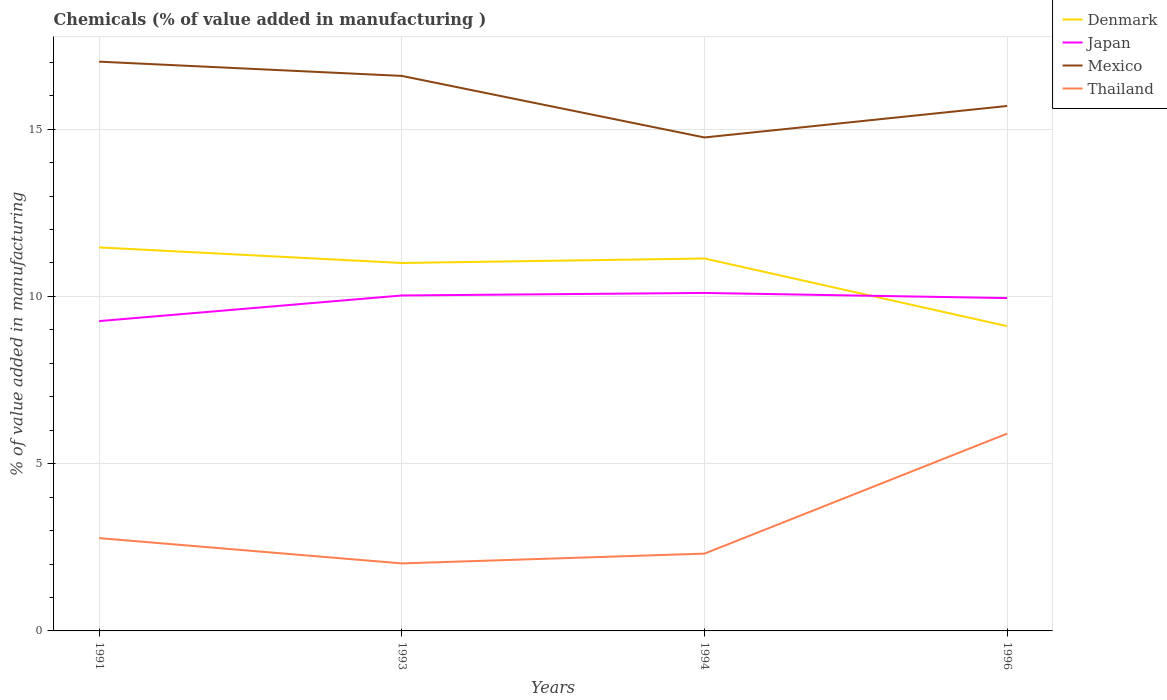How many different coloured lines are there?
Your response must be concise. 4. Does the line corresponding to Thailand intersect with the line corresponding to Japan?
Make the answer very short. No. Across all years, what is the maximum value added in manufacturing chemicals in Thailand?
Your answer should be compact. 2.02. What is the total value added in manufacturing chemicals in Japan in the graph?
Your answer should be compact. 0.15. What is the difference between the highest and the second highest value added in manufacturing chemicals in Mexico?
Ensure brevity in your answer.  2.27. How many years are there in the graph?
Provide a short and direct response. 4. Are the values on the major ticks of Y-axis written in scientific E-notation?
Offer a terse response. No. Does the graph contain any zero values?
Make the answer very short. No. Does the graph contain grids?
Your response must be concise. Yes. Where does the legend appear in the graph?
Provide a short and direct response. Top right. What is the title of the graph?
Offer a terse response. Chemicals (% of value added in manufacturing ). Does "Andorra" appear as one of the legend labels in the graph?
Offer a terse response. No. What is the label or title of the X-axis?
Offer a very short reply. Years. What is the label or title of the Y-axis?
Offer a very short reply. % of value added in manufacturing. What is the % of value added in manufacturing of Denmark in 1991?
Give a very brief answer. 11.47. What is the % of value added in manufacturing of Japan in 1991?
Your response must be concise. 9.26. What is the % of value added in manufacturing in Mexico in 1991?
Give a very brief answer. 17.02. What is the % of value added in manufacturing of Thailand in 1991?
Make the answer very short. 2.77. What is the % of value added in manufacturing in Denmark in 1993?
Offer a terse response. 11. What is the % of value added in manufacturing in Japan in 1993?
Give a very brief answer. 10.03. What is the % of value added in manufacturing of Mexico in 1993?
Provide a short and direct response. 16.59. What is the % of value added in manufacturing in Thailand in 1993?
Provide a succinct answer. 2.02. What is the % of value added in manufacturing of Denmark in 1994?
Make the answer very short. 11.13. What is the % of value added in manufacturing of Japan in 1994?
Provide a short and direct response. 10.1. What is the % of value added in manufacturing of Mexico in 1994?
Offer a very short reply. 14.75. What is the % of value added in manufacturing of Thailand in 1994?
Keep it short and to the point. 2.31. What is the % of value added in manufacturing of Denmark in 1996?
Your response must be concise. 9.11. What is the % of value added in manufacturing of Japan in 1996?
Your response must be concise. 9.95. What is the % of value added in manufacturing of Mexico in 1996?
Your answer should be very brief. 15.69. What is the % of value added in manufacturing of Thailand in 1996?
Offer a very short reply. 5.9. Across all years, what is the maximum % of value added in manufacturing in Denmark?
Provide a short and direct response. 11.47. Across all years, what is the maximum % of value added in manufacturing in Japan?
Provide a succinct answer. 10.1. Across all years, what is the maximum % of value added in manufacturing in Mexico?
Your response must be concise. 17.02. Across all years, what is the maximum % of value added in manufacturing in Thailand?
Provide a short and direct response. 5.9. Across all years, what is the minimum % of value added in manufacturing in Denmark?
Your response must be concise. 9.11. Across all years, what is the minimum % of value added in manufacturing in Japan?
Offer a very short reply. 9.26. Across all years, what is the minimum % of value added in manufacturing of Mexico?
Your answer should be very brief. 14.75. Across all years, what is the minimum % of value added in manufacturing in Thailand?
Provide a short and direct response. 2.02. What is the total % of value added in manufacturing of Denmark in the graph?
Keep it short and to the point. 42.71. What is the total % of value added in manufacturing of Japan in the graph?
Make the answer very short. 39.35. What is the total % of value added in manufacturing of Mexico in the graph?
Make the answer very short. 64.06. What is the total % of value added in manufacturing in Thailand in the graph?
Ensure brevity in your answer.  13. What is the difference between the % of value added in manufacturing of Denmark in 1991 and that in 1993?
Provide a succinct answer. 0.47. What is the difference between the % of value added in manufacturing of Japan in 1991 and that in 1993?
Provide a short and direct response. -0.77. What is the difference between the % of value added in manufacturing of Mexico in 1991 and that in 1993?
Make the answer very short. 0.43. What is the difference between the % of value added in manufacturing in Thailand in 1991 and that in 1993?
Ensure brevity in your answer.  0.76. What is the difference between the % of value added in manufacturing of Denmark in 1991 and that in 1994?
Offer a terse response. 0.33. What is the difference between the % of value added in manufacturing of Japan in 1991 and that in 1994?
Your response must be concise. -0.84. What is the difference between the % of value added in manufacturing in Mexico in 1991 and that in 1994?
Give a very brief answer. 2.27. What is the difference between the % of value added in manufacturing in Thailand in 1991 and that in 1994?
Provide a succinct answer. 0.46. What is the difference between the % of value added in manufacturing of Denmark in 1991 and that in 1996?
Offer a terse response. 2.35. What is the difference between the % of value added in manufacturing of Japan in 1991 and that in 1996?
Offer a terse response. -0.69. What is the difference between the % of value added in manufacturing in Mexico in 1991 and that in 1996?
Make the answer very short. 1.32. What is the difference between the % of value added in manufacturing in Thailand in 1991 and that in 1996?
Your answer should be compact. -3.12. What is the difference between the % of value added in manufacturing of Denmark in 1993 and that in 1994?
Your answer should be very brief. -0.13. What is the difference between the % of value added in manufacturing of Japan in 1993 and that in 1994?
Give a very brief answer. -0.08. What is the difference between the % of value added in manufacturing of Mexico in 1993 and that in 1994?
Your answer should be compact. 1.84. What is the difference between the % of value added in manufacturing in Thailand in 1993 and that in 1994?
Your answer should be compact. -0.29. What is the difference between the % of value added in manufacturing of Denmark in 1993 and that in 1996?
Provide a succinct answer. 1.89. What is the difference between the % of value added in manufacturing of Japan in 1993 and that in 1996?
Offer a very short reply. 0.08. What is the difference between the % of value added in manufacturing of Mexico in 1993 and that in 1996?
Offer a very short reply. 0.9. What is the difference between the % of value added in manufacturing of Thailand in 1993 and that in 1996?
Keep it short and to the point. -3.88. What is the difference between the % of value added in manufacturing in Denmark in 1994 and that in 1996?
Offer a terse response. 2.02. What is the difference between the % of value added in manufacturing of Japan in 1994 and that in 1996?
Ensure brevity in your answer.  0.15. What is the difference between the % of value added in manufacturing of Mexico in 1994 and that in 1996?
Offer a terse response. -0.94. What is the difference between the % of value added in manufacturing of Thailand in 1994 and that in 1996?
Your answer should be compact. -3.59. What is the difference between the % of value added in manufacturing in Denmark in 1991 and the % of value added in manufacturing in Japan in 1993?
Your response must be concise. 1.44. What is the difference between the % of value added in manufacturing of Denmark in 1991 and the % of value added in manufacturing of Mexico in 1993?
Offer a very short reply. -5.13. What is the difference between the % of value added in manufacturing in Denmark in 1991 and the % of value added in manufacturing in Thailand in 1993?
Offer a terse response. 9.45. What is the difference between the % of value added in manufacturing in Japan in 1991 and the % of value added in manufacturing in Mexico in 1993?
Provide a succinct answer. -7.33. What is the difference between the % of value added in manufacturing of Japan in 1991 and the % of value added in manufacturing of Thailand in 1993?
Your response must be concise. 7.24. What is the difference between the % of value added in manufacturing in Mexico in 1991 and the % of value added in manufacturing in Thailand in 1993?
Offer a very short reply. 15. What is the difference between the % of value added in manufacturing of Denmark in 1991 and the % of value added in manufacturing of Japan in 1994?
Give a very brief answer. 1.36. What is the difference between the % of value added in manufacturing of Denmark in 1991 and the % of value added in manufacturing of Mexico in 1994?
Give a very brief answer. -3.29. What is the difference between the % of value added in manufacturing in Denmark in 1991 and the % of value added in manufacturing in Thailand in 1994?
Offer a terse response. 9.15. What is the difference between the % of value added in manufacturing in Japan in 1991 and the % of value added in manufacturing in Mexico in 1994?
Your answer should be compact. -5.49. What is the difference between the % of value added in manufacturing in Japan in 1991 and the % of value added in manufacturing in Thailand in 1994?
Offer a very short reply. 6.95. What is the difference between the % of value added in manufacturing in Mexico in 1991 and the % of value added in manufacturing in Thailand in 1994?
Give a very brief answer. 14.71. What is the difference between the % of value added in manufacturing of Denmark in 1991 and the % of value added in manufacturing of Japan in 1996?
Your answer should be very brief. 1.52. What is the difference between the % of value added in manufacturing in Denmark in 1991 and the % of value added in manufacturing in Mexico in 1996?
Offer a terse response. -4.23. What is the difference between the % of value added in manufacturing in Denmark in 1991 and the % of value added in manufacturing in Thailand in 1996?
Offer a very short reply. 5.57. What is the difference between the % of value added in manufacturing in Japan in 1991 and the % of value added in manufacturing in Mexico in 1996?
Keep it short and to the point. -6.43. What is the difference between the % of value added in manufacturing in Japan in 1991 and the % of value added in manufacturing in Thailand in 1996?
Provide a short and direct response. 3.36. What is the difference between the % of value added in manufacturing in Mexico in 1991 and the % of value added in manufacturing in Thailand in 1996?
Your response must be concise. 11.12. What is the difference between the % of value added in manufacturing in Denmark in 1993 and the % of value added in manufacturing in Japan in 1994?
Offer a very short reply. 0.9. What is the difference between the % of value added in manufacturing of Denmark in 1993 and the % of value added in manufacturing of Mexico in 1994?
Offer a very short reply. -3.75. What is the difference between the % of value added in manufacturing of Denmark in 1993 and the % of value added in manufacturing of Thailand in 1994?
Ensure brevity in your answer.  8.69. What is the difference between the % of value added in manufacturing in Japan in 1993 and the % of value added in manufacturing in Mexico in 1994?
Offer a very short reply. -4.72. What is the difference between the % of value added in manufacturing in Japan in 1993 and the % of value added in manufacturing in Thailand in 1994?
Your answer should be very brief. 7.72. What is the difference between the % of value added in manufacturing in Mexico in 1993 and the % of value added in manufacturing in Thailand in 1994?
Provide a succinct answer. 14.28. What is the difference between the % of value added in manufacturing in Denmark in 1993 and the % of value added in manufacturing in Japan in 1996?
Offer a terse response. 1.05. What is the difference between the % of value added in manufacturing of Denmark in 1993 and the % of value added in manufacturing of Mexico in 1996?
Offer a terse response. -4.69. What is the difference between the % of value added in manufacturing in Denmark in 1993 and the % of value added in manufacturing in Thailand in 1996?
Keep it short and to the point. 5.1. What is the difference between the % of value added in manufacturing of Japan in 1993 and the % of value added in manufacturing of Mexico in 1996?
Provide a short and direct response. -5.67. What is the difference between the % of value added in manufacturing in Japan in 1993 and the % of value added in manufacturing in Thailand in 1996?
Keep it short and to the point. 4.13. What is the difference between the % of value added in manufacturing of Mexico in 1993 and the % of value added in manufacturing of Thailand in 1996?
Your answer should be compact. 10.69. What is the difference between the % of value added in manufacturing in Denmark in 1994 and the % of value added in manufacturing in Japan in 1996?
Your answer should be compact. 1.18. What is the difference between the % of value added in manufacturing of Denmark in 1994 and the % of value added in manufacturing of Mexico in 1996?
Provide a succinct answer. -4.56. What is the difference between the % of value added in manufacturing of Denmark in 1994 and the % of value added in manufacturing of Thailand in 1996?
Offer a terse response. 5.23. What is the difference between the % of value added in manufacturing of Japan in 1994 and the % of value added in manufacturing of Mexico in 1996?
Offer a terse response. -5.59. What is the difference between the % of value added in manufacturing of Japan in 1994 and the % of value added in manufacturing of Thailand in 1996?
Your response must be concise. 4.21. What is the difference between the % of value added in manufacturing of Mexico in 1994 and the % of value added in manufacturing of Thailand in 1996?
Your answer should be compact. 8.85. What is the average % of value added in manufacturing of Denmark per year?
Make the answer very short. 10.68. What is the average % of value added in manufacturing of Japan per year?
Make the answer very short. 9.84. What is the average % of value added in manufacturing in Mexico per year?
Your answer should be very brief. 16.01. What is the average % of value added in manufacturing of Thailand per year?
Provide a short and direct response. 3.25. In the year 1991, what is the difference between the % of value added in manufacturing of Denmark and % of value added in manufacturing of Japan?
Make the answer very short. 2.2. In the year 1991, what is the difference between the % of value added in manufacturing in Denmark and % of value added in manufacturing in Mexico?
Offer a very short reply. -5.55. In the year 1991, what is the difference between the % of value added in manufacturing of Denmark and % of value added in manufacturing of Thailand?
Your answer should be compact. 8.69. In the year 1991, what is the difference between the % of value added in manufacturing in Japan and % of value added in manufacturing in Mexico?
Provide a succinct answer. -7.76. In the year 1991, what is the difference between the % of value added in manufacturing of Japan and % of value added in manufacturing of Thailand?
Your response must be concise. 6.49. In the year 1991, what is the difference between the % of value added in manufacturing in Mexico and % of value added in manufacturing in Thailand?
Make the answer very short. 14.24. In the year 1993, what is the difference between the % of value added in manufacturing of Denmark and % of value added in manufacturing of Japan?
Give a very brief answer. 0.97. In the year 1993, what is the difference between the % of value added in manufacturing in Denmark and % of value added in manufacturing in Mexico?
Offer a terse response. -5.59. In the year 1993, what is the difference between the % of value added in manufacturing of Denmark and % of value added in manufacturing of Thailand?
Your response must be concise. 8.98. In the year 1993, what is the difference between the % of value added in manufacturing of Japan and % of value added in manufacturing of Mexico?
Offer a terse response. -6.56. In the year 1993, what is the difference between the % of value added in manufacturing of Japan and % of value added in manufacturing of Thailand?
Make the answer very short. 8.01. In the year 1993, what is the difference between the % of value added in manufacturing of Mexico and % of value added in manufacturing of Thailand?
Your answer should be very brief. 14.57. In the year 1994, what is the difference between the % of value added in manufacturing of Denmark and % of value added in manufacturing of Japan?
Your response must be concise. 1.03. In the year 1994, what is the difference between the % of value added in manufacturing of Denmark and % of value added in manufacturing of Mexico?
Provide a short and direct response. -3.62. In the year 1994, what is the difference between the % of value added in manufacturing in Denmark and % of value added in manufacturing in Thailand?
Give a very brief answer. 8.82. In the year 1994, what is the difference between the % of value added in manufacturing in Japan and % of value added in manufacturing in Mexico?
Your answer should be very brief. -4.65. In the year 1994, what is the difference between the % of value added in manufacturing of Japan and % of value added in manufacturing of Thailand?
Provide a short and direct response. 7.79. In the year 1994, what is the difference between the % of value added in manufacturing of Mexico and % of value added in manufacturing of Thailand?
Give a very brief answer. 12.44. In the year 1996, what is the difference between the % of value added in manufacturing of Denmark and % of value added in manufacturing of Japan?
Your answer should be compact. -0.84. In the year 1996, what is the difference between the % of value added in manufacturing of Denmark and % of value added in manufacturing of Mexico?
Make the answer very short. -6.58. In the year 1996, what is the difference between the % of value added in manufacturing in Denmark and % of value added in manufacturing in Thailand?
Give a very brief answer. 3.21. In the year 1996, what is the difference between the % of value added in manufacturing in Japan and % of value added in manufacturing in Mexico?
Your answer should be very brief. -5.74. In the year 1996, what is the difference between the % of value added in manufacturing of Japan and % of value added in manufacturing of Thailand?
Keep it short and to the point. 4.05. In the year 1996, what is the difference between the % of value added in manufacturing of Mexico and % of value added in manufacturing of Thailand?
Provide a succinct answer. 9.79. What is the ratio of the % of value added in manufacturing in Denmark in 1991 to that in 1993?
Your response must be concise. 1.04. What is the ratio of the % of value added in manufacturing of Japan in 1991 to that in 1993?
Your answer should be compact. 0.92. What is the ratio of the % of value added in manufacturing in Mexico in 1991 to that in 1993?
Keep it short and to the point. 1.03. What is the ratio of the % of value added in manufacturing in Thailand in 1991 to that in 1993?
Your response must be concise. 1.37. What is the ratio of the % of value added in manufacturing in Denmark in 1991 to that in 1994?
Give a very brief answer. 1.03. What is the ratio of the % of value added in manufacturing in Mexico in 1991 to that in 1994?
Offer a terse response. 1.15. What is the ratio of the % of value added in manufacturing in Thailand in 1991 to that in 1994?
Your answer should be compact. 1.2. What is the ratio of the % of value added in manufacturing of Denmark in 1991 to that in 1996?
Your answer should be very brief. 1.26. What is the ratio of the % of value added in manufacturing in Japan in 1991 to that in 1996?
Offer a very short reply. 0.93. What is the ratio of the % of value added in manufacturing of Mexico in 1991 to that in 1996?
Your answer should be compact. 1.08. What is the ratio of the % of value added in manufacturing of Thailand in 1991 to that in 1996?
Offer a terse response. 0.47. What is the ratio of the % of value added in manufacturing of Denmark in 1993 to that in 1994?
Ensure brevity in your answer.  0.99. What is the ratio of the % of value added in manufacturing in Japan in 1993 to that in 1994?
Ensure brevity in your answer.  0.99. What is the ratio of the % of value added in manufacturing of Mexico in 1993 to that in 1994?
Offer a terse response. 1.12. What is the ratio of the % of value added in manufacturing in Thailand in 1993 to that in 1994?
Provide a short and direct response. 0.87. What is the ratio of the % of value added in manufacturing of Denmark in 1993 to that in 1996?
Keep it short and to the point. 1.21. What is the ratio of the % of value added in manufacturing in Japan in 1993 to that in 1996?
Your answer should be very brief. 1.01. What is the ratio of the % of value added in manufacturing in Mexico in 1993 to that in 1996?
Offer a very short reply. 1.06. What is the ratio of the % of value added in manufacturing of Thailand in 1993 to that in 1996?
Keep it short and to the point. 0.34. What is the ratio of the % of value added in manufacturing in Denmark in 1994 to that in 1996?
Your answer should be compact. 1.22. What is the ratio of the % of value added in manufacturing in Japan in 1994 to that in 1996?
Keep it short and to the point. 1.02. What is the ratio of the % of value added in manufacturing of Mexico in 1994 to that in 1996?
Make the answer very short. 0.94. What is the ratio of the % of value added in manufacturing in Thailand in 1994 to that in 1996?
Ensure brevity in your answer.  0.39. What is the difference between the highest and the second highest % of value added in manufacturing in Denmark?
Give a very brief answer. 0.33. What is the difference between the highest and the second highest % of value added in manufacturing in Japan?
Your response must be concise. 0.08. What is the difference between the highest and the second highest % of value added in manufacturing in Mexico?
Your response must be concise. 0.43. What is the difference between the highest and the second highest % of value added in manufacturing of Thailand?
Provide a succinct answer. 3.12. What is the difference between the highest and the lowest % of value added in manufacturing of Denmark?
Keep it short and to the point. 2.35. What is the difference between the highest and the lowest % of value added in manufacturing of Japan?
Provide a short and direct response. 0.84. What is the difference between the highest and the lowest % of value added in manufacturing of Mexico?
Your answer should be very brief. 2.27. What is the difference between the highest and the lowest % of value added in manufacturing of Thailand?
Offer a very short reply. 3.88. 